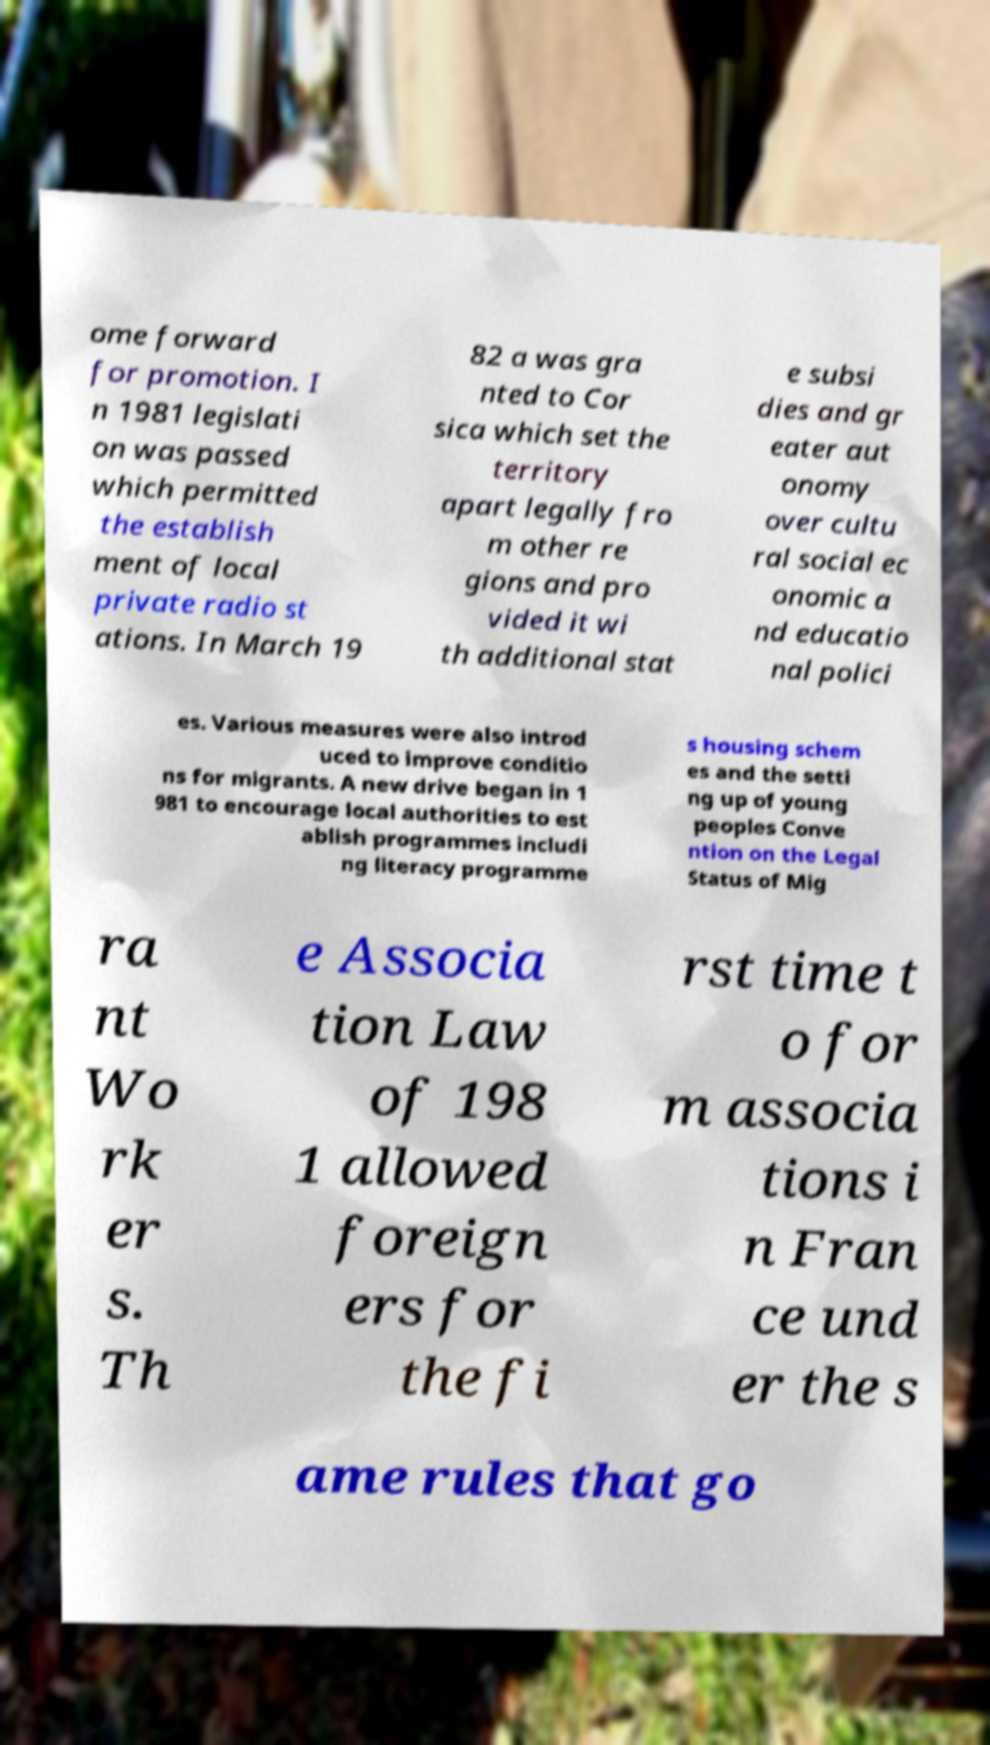For documentation purposes, I need the text within this image transcribed. Could you provide that? ome forward for promotion. I n 1981 legislati on was passed which permitted the establish ment of local private radio st ations. In March 19 82 a was gra nted to Cor sica which set the territory apart legally fro m other re gions and pro vided it wi th additional stat e subsi dies and gr eater aut onomy over cultu ral social ec onomic a nd educatio nal polici es. Various measures were also introd uced to improve conditio ns for migrants. A new drive began in 1 981 to encourage local authorities to est ablish programmes includi ng literacy programme s housing schem es and the setti ng up of young peoples Conve ntion on the Legal Status of Mig ra nt Wo rk er s. Th e Associa tion Law of 198 1 allowed foreign ers for the fi rst time t o for m associa tions i n Fran ce und er the s ame rules that go 